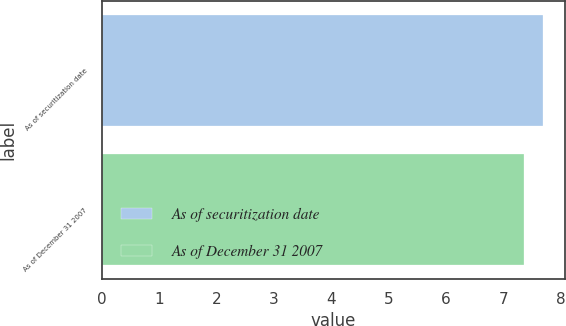Convert chart to OTSL. <chart><loc_0><loc_0><loc_500><loc_500><bar_chart><fcel>As of securitization date<fcel>As of December 31 2007<nl><fcel>7.68<fcel>7.36<nl></chart> 